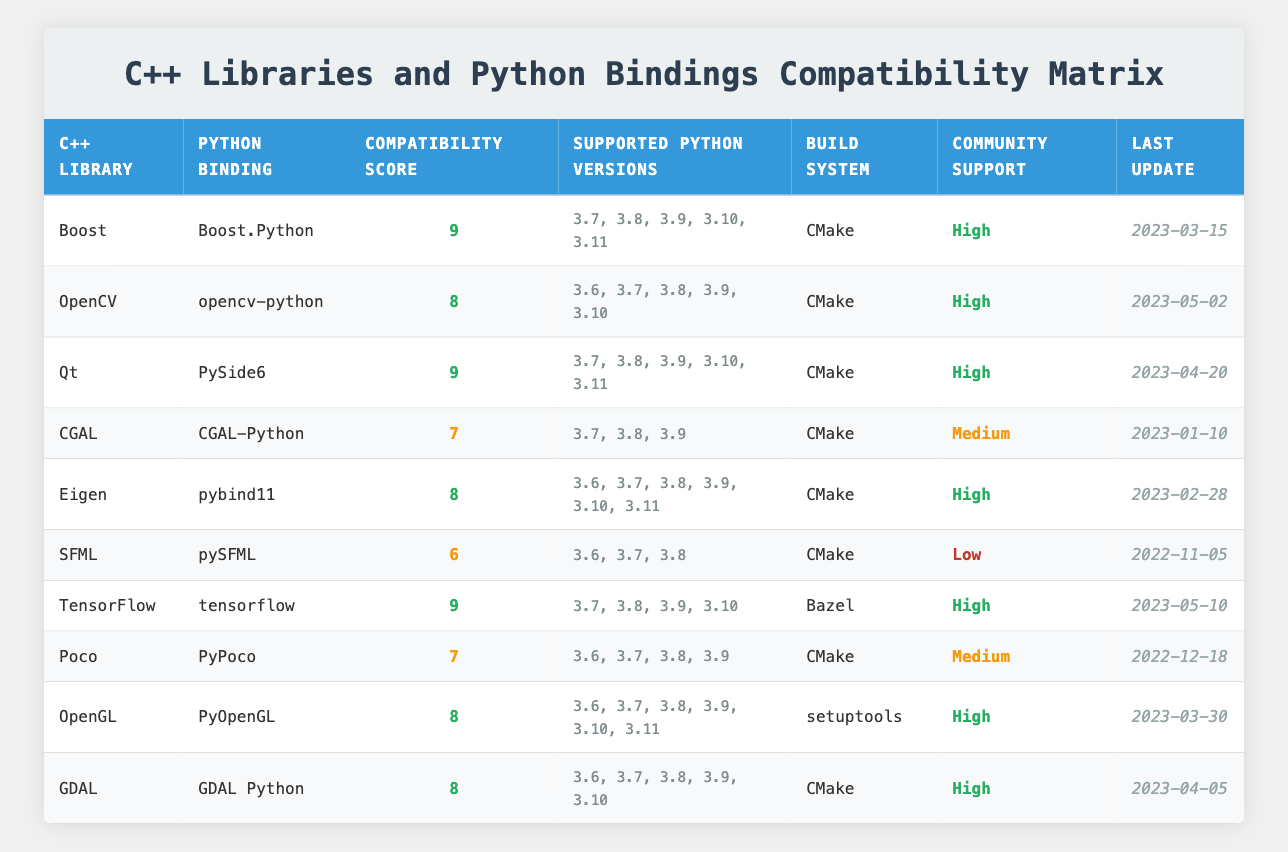What is the compatibility score for Boost? The table lists Boost under the C++ Libraries column and shows its compatibility score in the third column as 9.
Answer: 9 How many Python versions are supported by TensorFlow? For TensorFlow, the supported Python versions are listed in the fourth column, which shows 4 versions: 3.7, 3.8, 3.9, and 3.10.
Answer: 4 Which C++ library has the highest compatibility score? By examining the compatibility scores, both Boost and TensorFlow have the highest score of 9, making them the top libraries in this aspect.
Answer: Boost, TensorFlow Is CGAL-Python supported on Python 3.6? Looking under CGAL in the table, the supported Python versions are 3.7, 3.8, and 3.9. Python 3.6 is not listed.
Answer: No What are the community support levels for libraries with a compatibility score of 8? The libraries with a compatibility score of 8 are OpenCV, Eigen, OpenGL, and GDAL. Checking the community support, all these libraries have a "High" support level.
Answer: High Which C++ library has the least community support? Reviewing the community support column, SFML has a support level listed as "Low," making it the library with the least community support.
Answer: SFML How many libraries use CMake as their build system? From the table, counting the rows that indicate "CMake" in the build system column, we find that 7 libraries (Boost, OpenCV, Qt, CGAL, Eigen, Poco, GDAL) use CMake.
Answer: 7 What is the last update date for the Python binding pySFML? Looking at pySFML in the table, its last update date is shown in the last column as "2022-11-05."
Answer: 2022-11-05 What is the average compatibility score of libraries with "High" community support? First, we identify the libraries with "High" community support: Boost (9), OpenCV (8), Qt (9), Eigen (8), TensorFlow (9), OpenGL (8), GDAL (8). The total score is 9 + 8 + 9 + 8 + 9 + 8 + 8 = 59 and there are 7 libraries, leading to an average of 59/7 = 8.43.
Answer: 8.43 